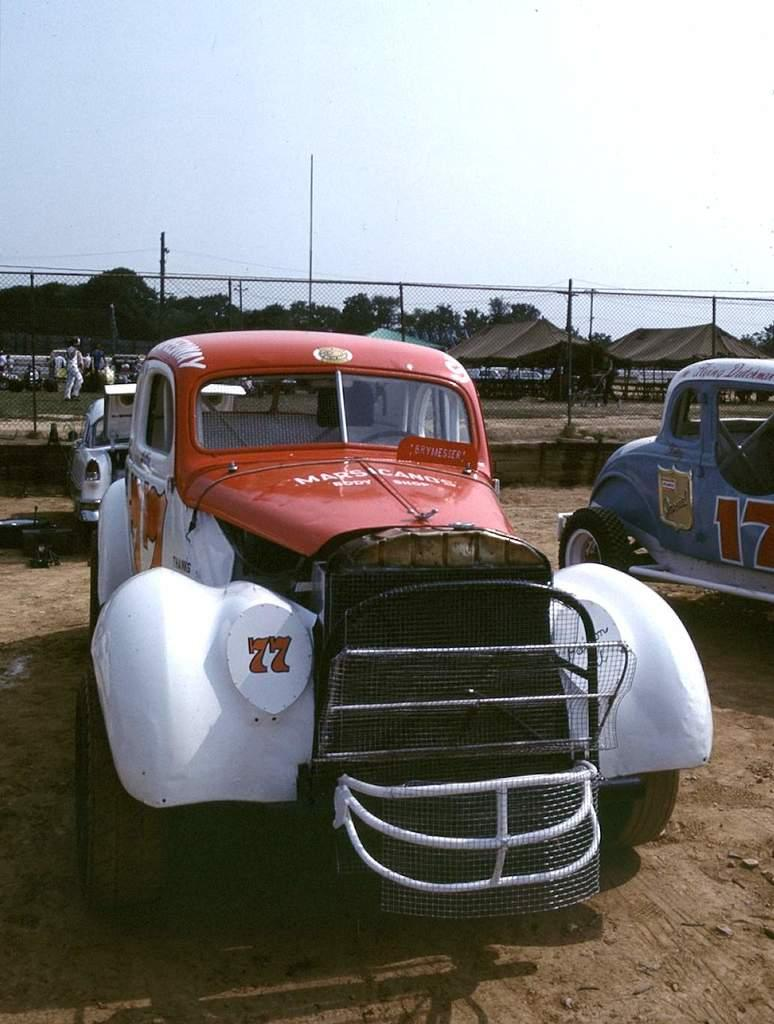What types of objects can be seen in the image? There are vehicles, trees, a fence, a person, and tents in the image. What can be seen in the background of the image? Trees and the sky are visible in the background of the image. What is the person in the image doing? The person's actions are not specified, but they are present in the image. What is the purpose of the fence in the image? The purpose of the fence is not specified, but it is present in the image. What color is the sweater worn by the elbow in the image? There is no sweater or elbow present in the image. How is the person in the image measuring the distance between the tents? There is no indication of measuring or distance between tents in the image. 